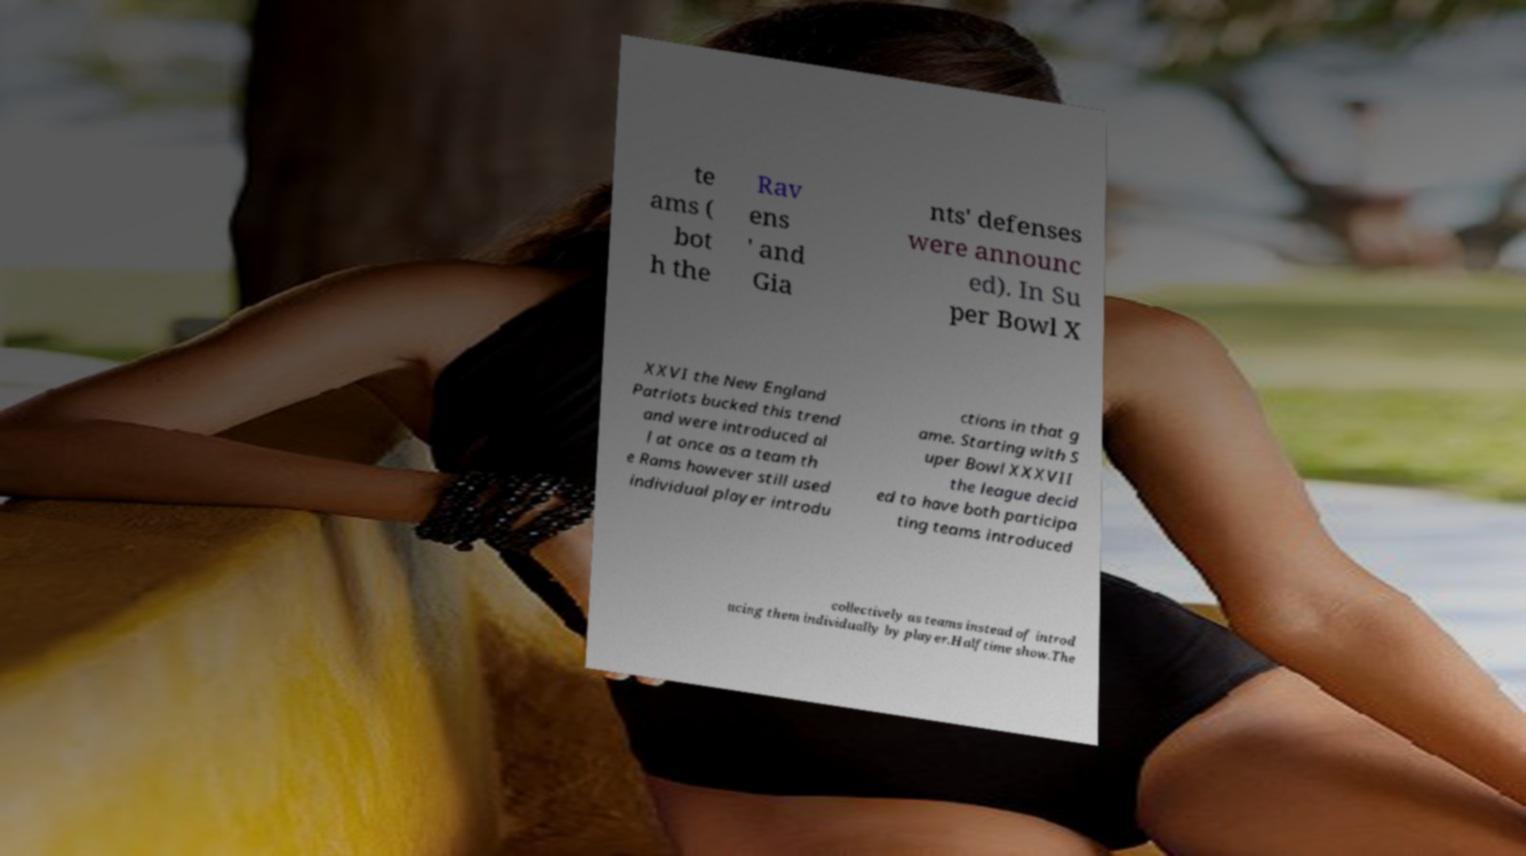There's text embedded in this image that I need extracted. Can you transcribe it verbatim? te ams ( bot h the Rav ens ' and Gia nts' defenses were announc ed). In Su per Bowl X XXVI the New England Patriots bucked this trend and were introduced al l at once as a team th e Rams however still used individual player introdu ctions in that g ame. Starting with S uper Bowl XXXVII the league decid ed to have both participa ting teams introduced collectively as teams instead of introd ucing them individually by player.Halftime show.The 